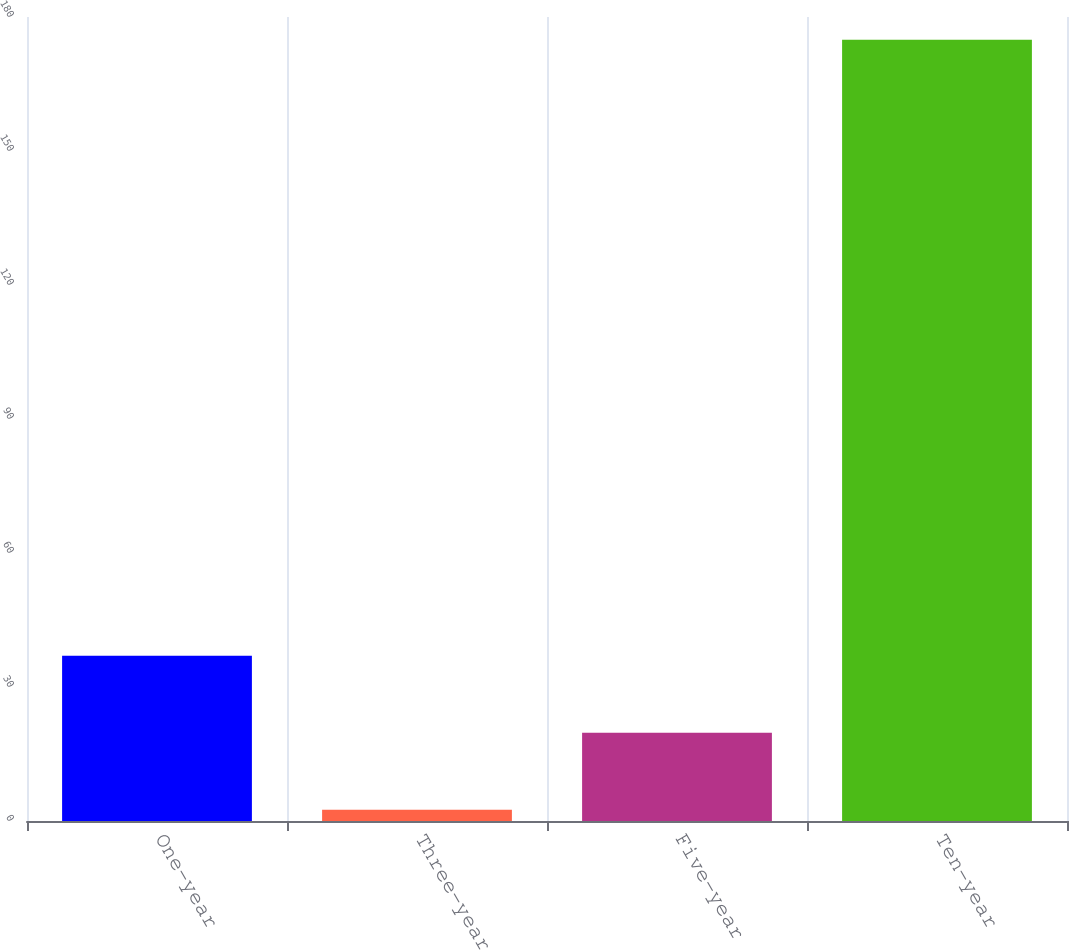Convert chart. <chart><loc_0><loc_0><loc_500><loc_500><bar_chart><fcel>One-year<fcel>Three-year<fcel>Five-year<fcel>Ten-year<nl><fcel>36.98<fcel>2.5<fcel>19.74<fcel>174.9<nl></chart> 